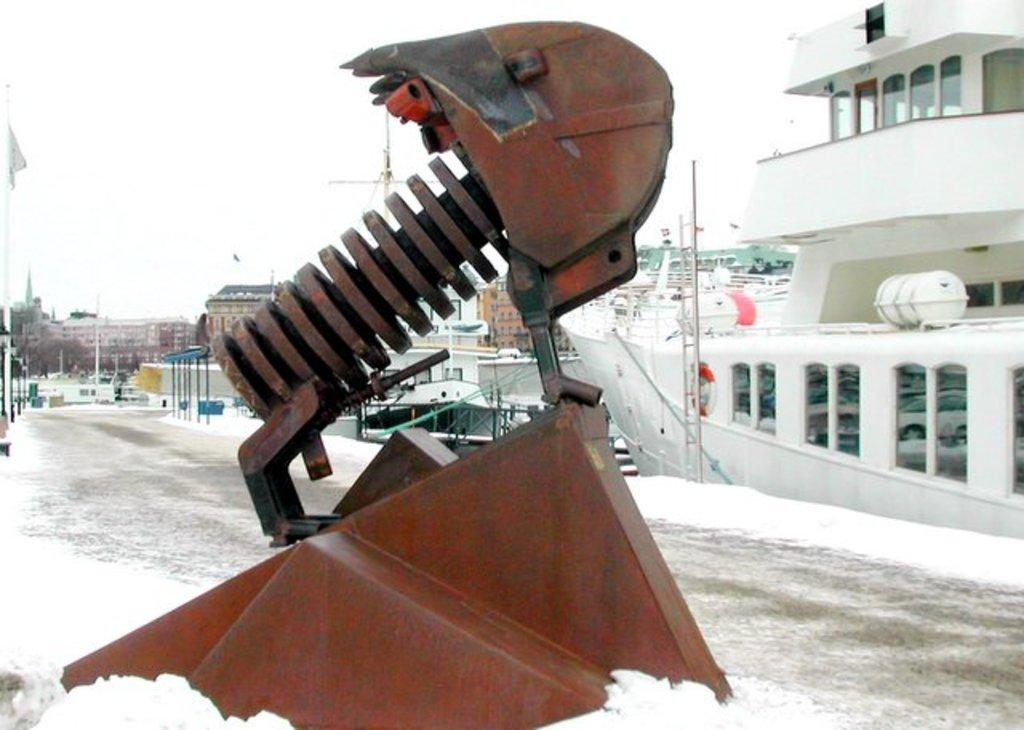What is the main object in the image? There is a machine in the image. What is the weather like in the image? There is snow in the image. What type of vehicle is present in the image? There is a ship in the image. What can be seen in the background of the image? There are buildings, poles, trees, and the sky visible in the background of the image. What type of wire is being used to tie the kitten to the pole in the image? There is no kitten or wire present in the image. What type of harbor is visible in the image? There is no harbor visible in the image. 